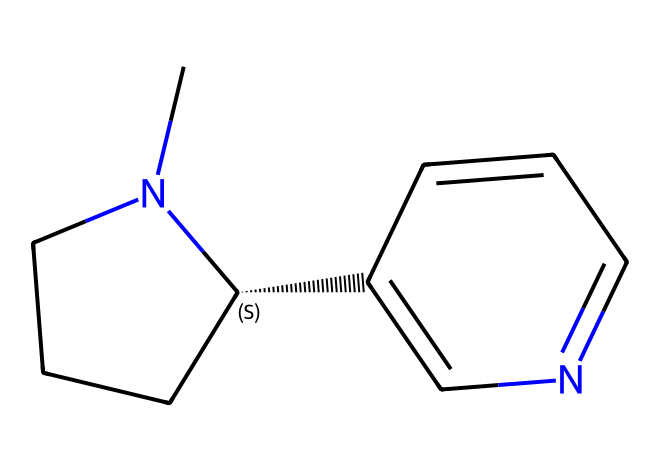What is the molecular formula of nicotine? The molecular formula can be derived by counting the number of carbon (C), hydrogen (H), and nitrogen (N) atoms in the structure. There are 10 carbon atoms, 14 hydrogen atoms, and 2 nitrogen atoms, leading to the formula C10H14N2.
Answer: C10H14N2 How many rings are present in the nicotine structure? By examining the structure, it's clear that there are two fused ring systems. One is a five-membered ring, and the other is a six-membered ring, indicating a total of two rings.
Answer: 2 What type of chemical compound is nicotine? Nicotine is classified as an alkaloid due to the presence of nitrogen atoms and its physiological effects, which are characteristic of this group of organic compounds.
Answer: alkaloid What is the significance of the nitrogen atom in the nicotine structure? The nitrogen atom in nicotine plays a crucial role in its function as a neurotransmitter. It contributes to bonding with receptors, making it a key player in the stimulating properties of nicotine.
Answer: neurotransmitter Are there any double bonds present in the nicotine structure? By inspecting the structure, we can identify that the double bonds are indicated by the lines connecting the carbon and nitrogen atoms in the fused rings, confirming that double bonds are present in the molecule.
Answer: yes What is the stereochemistry of the chiral center in nicotine? There is a chiral center in the structure, indicated by the carbon atom that is attached to four different substituents. The stereochemical configuration is represented as (S) due to its specific spatial arrangement.
Answer: S 